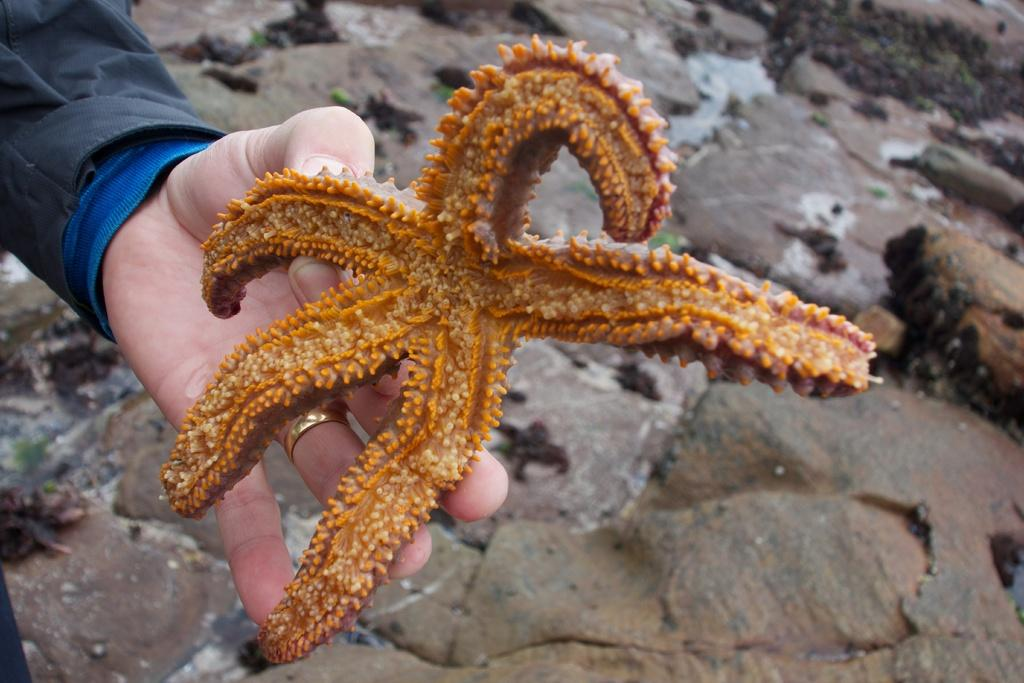What is the person holding in their hand in the image? The person is holding a starfish in their hand. What type of natural features can be seen in the image? There are rocks with small plants and grass visible in the image. Can you describe any jewelry the person is wearing? The person is wearing a gold ring on their finger. How many frogs can be seen hopping in the grass in the image? There are no frogs visible in the image; it features a person holding a starfish and natural features such as rocks and grass. What type of fruit is being used as a decoration on the rocks in the image? There are no fruits, including oranges, present in the image. 